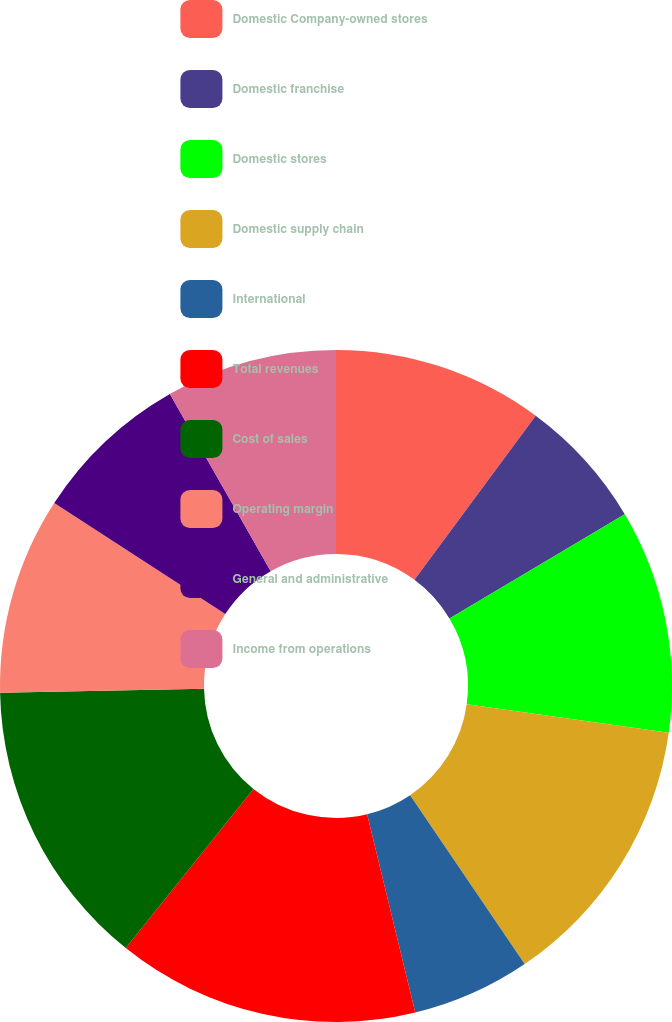Convert chart. <chart><loc_0><loc_0><loc_500><loc_500><pie_chart><fcel>Domestic Company-owned stores<fcel>Domestic franchise<fcel>Domestic stores<fcel>Domestic supply chain<fcel>International<fcel>Total revenues<fcel>Cost of sales<fcel>Operating margin<fcel>General and administrative<fcel>Income from operations<nl><fcel>10.13%<fcel>6.33%<fcel>10.76%<fcel>13.29%<fcel>5.7%<fcel>14.55%<fcel>13.92%<fcel>9.49%<fcel>7.6%<fcel>8.23%<nl></chart> 